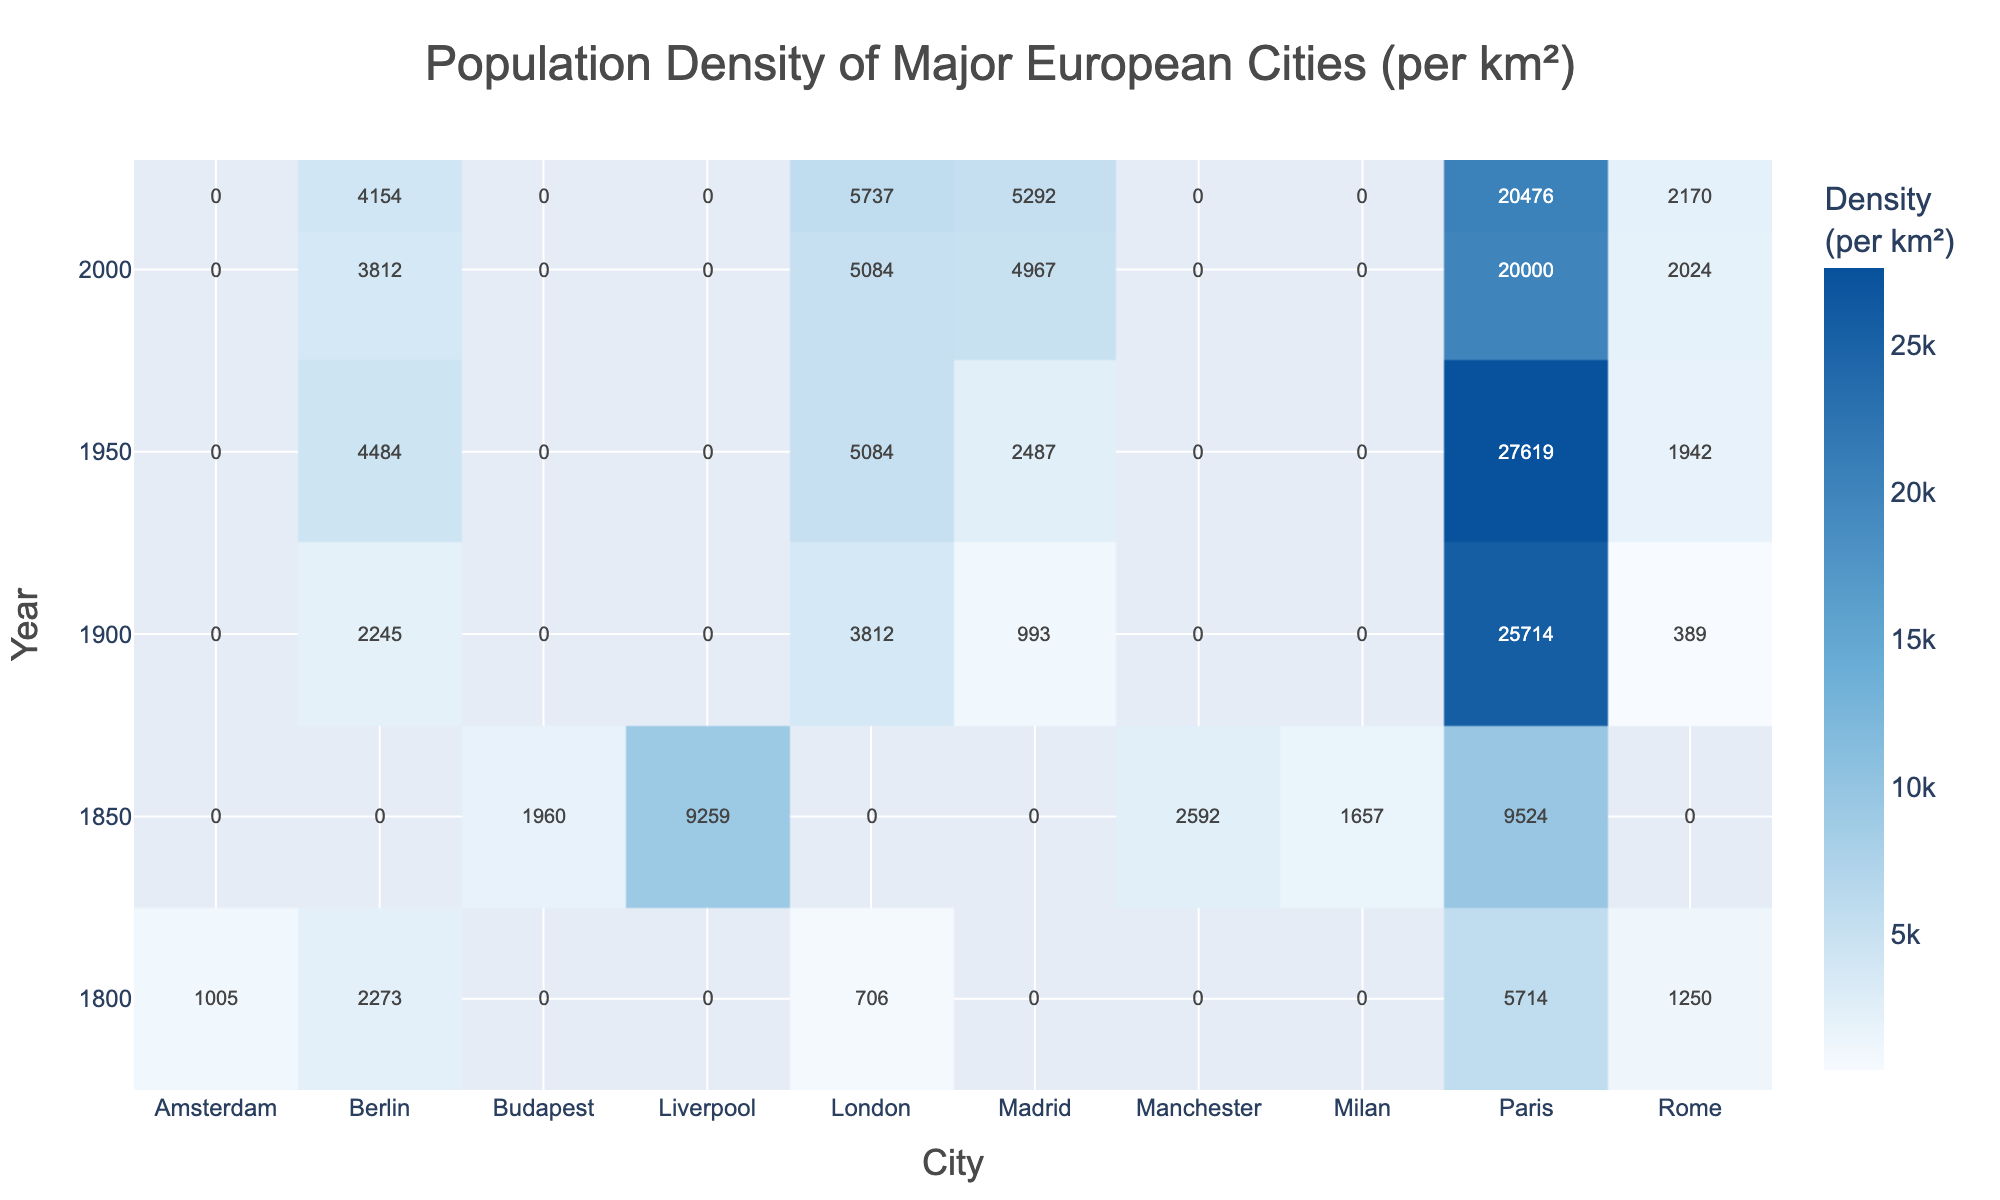What was the population density of London in 1900? According to the table, the population density of London in 1900 is directly listed as 3812 per km².
Answer: 3812 Which city had the highest population density in 1850? By inspecting the values for 1850, Liverpool has a population density of 9259 per km², which is the highest among all cities at that time.
Answer: Liverpool What is the difference in population density of Paris between 1900 and 1950? For Paris, the population density in 1900 is 25714 per km² and in 1950 it is 27619 per km². The difference is calculated as 27619 - 25714 = 1905.
Answer: 1905 Which city showed the largest increase in population density from 1800 to 2020? To assess the increase, we observe the population density of all cities in 1800 and their respective values in 2020. For instance, London increased from 706 to 5737, an increase of 5031. Similarly, Paris increased from 5714 to 20476. Comparing these increases, Paris had a larger increase of 14762.
Answer: Paris Was the population density of Berlin higher in 2000 or 2020? By looking at the values, Berlin had a population density of 3812 in 2000 and 4154 in 2020. Since 4154 is greater than 3812, Berlin had a higher density in 2020.
Answer: Yes What was the average population density of Madrid from 1850 to 2020? For Madrid, the population densities over available years are 993 (1900), 2487 (1950), 4967 (2000), and 5292 (2020). We calculate the average: (993 + 2487 + 4967 + 5292) / 4 = 3439.75, which rounds to 3440.
Answer: 3440 Which city had the lowest population density in 1900? In 1900, the population densities were London (3812), Berlin (2245), Paris (25714), Madrid (993), and Rome (389). The lowest value is for Madrid at 993 per km².
Answer: Madrid What trend do you observe for the population density of Paris from 1800 to 2020? Observing the table, Paris shows a consistent increase in population density: it grew from 5714 in 1800 to 20476 in 2020. This indicates a significant growth trend over two centuries.
Answer: Increase Did any city maintain a constant population density between 1800 and 2020? Based on the table, we can see that although population densities fluctuate over the years for cities, none of them maintained the same density across the years presented.
Answer: No What is the overall increase in population density of Rome from 1800 to 2020? For Rome, the population density in 1800 was 1250, and by 2020 it had risen to 2170. The increase is calculated as 2170 - 1250 = 920, indicating significant growth.
Answer: 920 